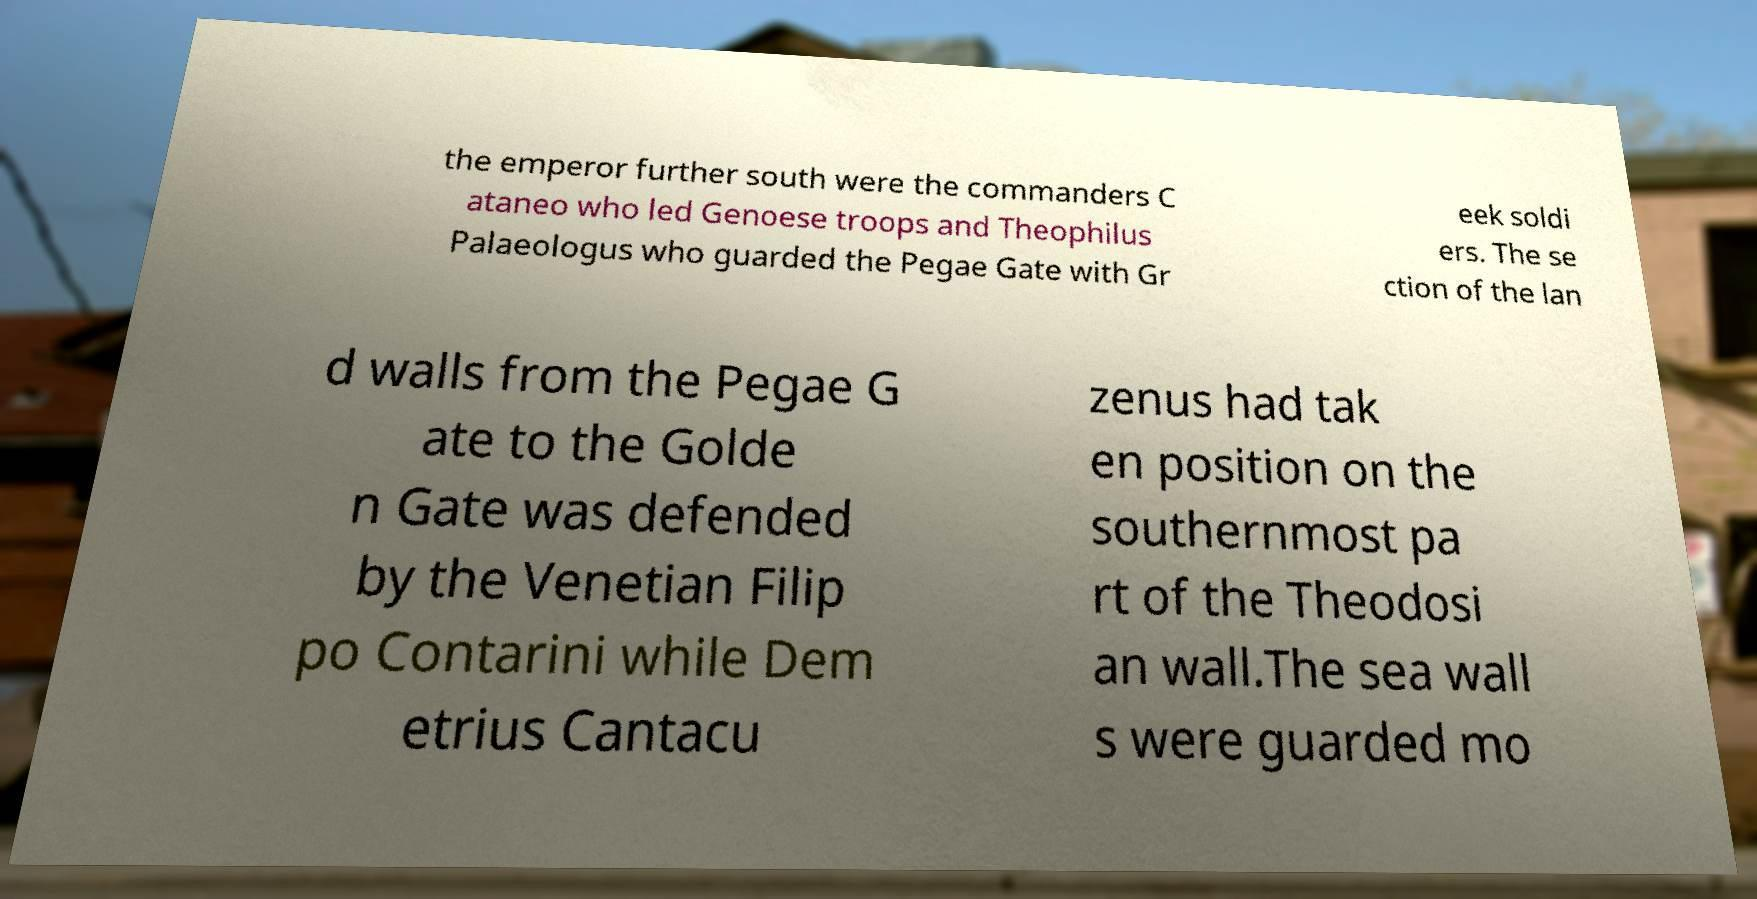Please read and relay the text visible in this image. What does it say? the emperor further south were the commanders C ataneo who led Genoese troops and Theophilus Palaeologus who guarded the Pegae Gate with Gr eek soldi ers. The se ction of the lan d walls from the Pegae G ate to the Golde n Gate was defended by the Venetian Filip po Contarini while Dem etrius Cantacu zenus had tak en position on the southernmost pa rt of the Theodosi an wall.The sea wall s were guarded mo 